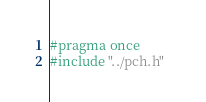Convert code to text. <code><loc_0><loc_0><loc_500><loc_500><_C_>#pragma once
#include "../pch.h"  </code> 